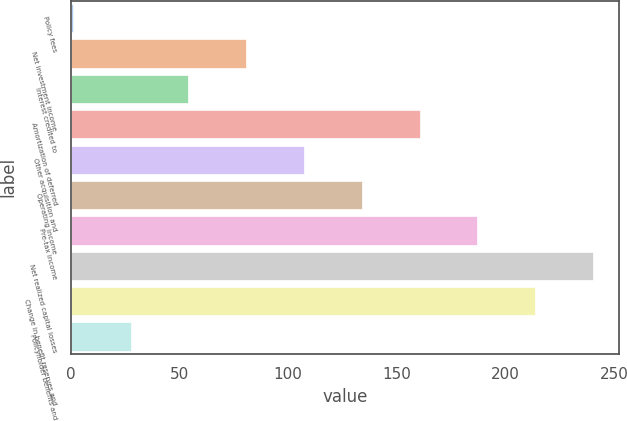Convert chart to OTSL. <chart><loc_0><loc_0><loc_500><loc_500><bar_chart><fcel>Policy fees<fcel>Net investment income<fcel>Interest credited to<fcel>Amortization of deferred<fcel>Other acquisition and<fcel>Operating income<fcel>Pre-tax income<fcel>Net realized capital losses<fcel>Change in benefit reserves and<fcel>Policyholder benefits and<nl><fcel>1<fcel>80.8<fcel>54.2<fcel>160.6<fcel>107.4<fcel>134<fcel>187.2<fcel>240.4<fcel>213.8<fcel>27.6<nl></chart> 